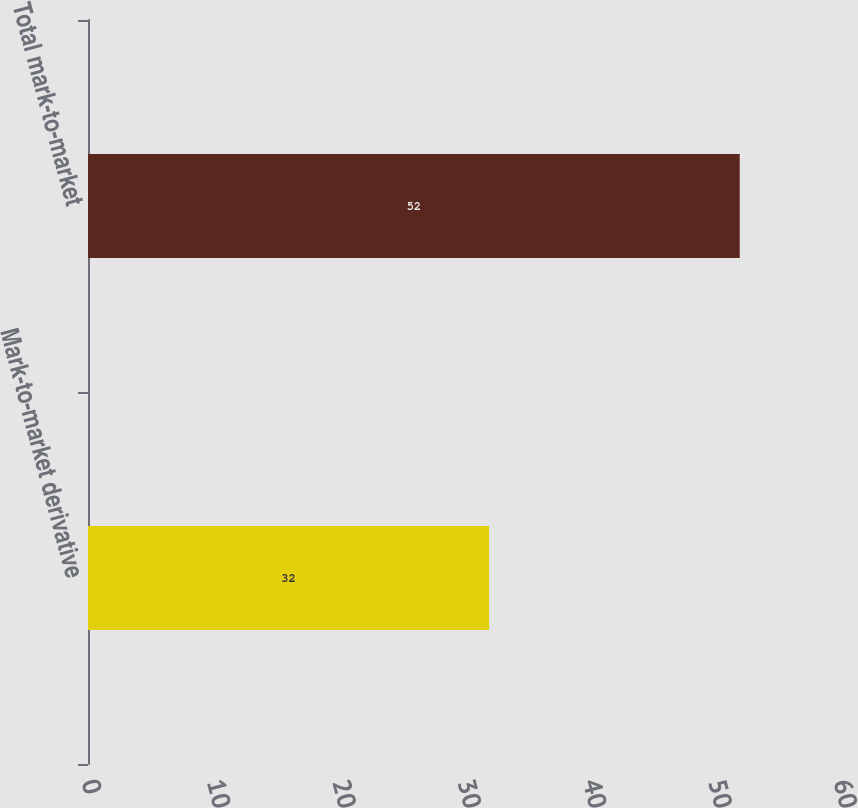Convert chart to OTSL. <chart><loc_0><loc_0><loc_500><loc_500><bar_chart><fcel>Mark-to-market derivative<fcel>Total mark-to-market<nl><fcel>32<fcel>52<nl></chart> 